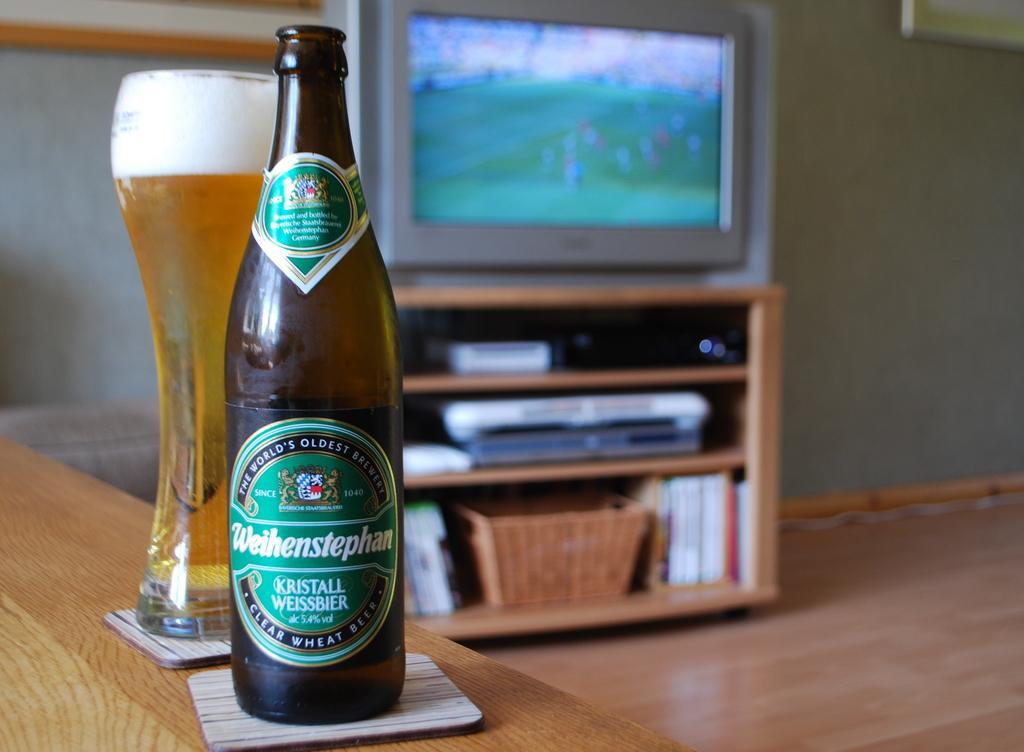<image>
Offer a succinct explanation of the picture presented. A bottle of Weihenstephan beer on a coaster 